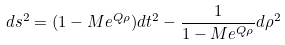<formula> <loc_0><loc_0><loc_500><loc_500>d s ^ { 2 } = ( 1 - M e ^ { Q \rho } ) d t ^ { 2 } - \frac { 1 } { 1 - M e ^ { Q \rho } } d \rho ^ { 2 }</formula> 